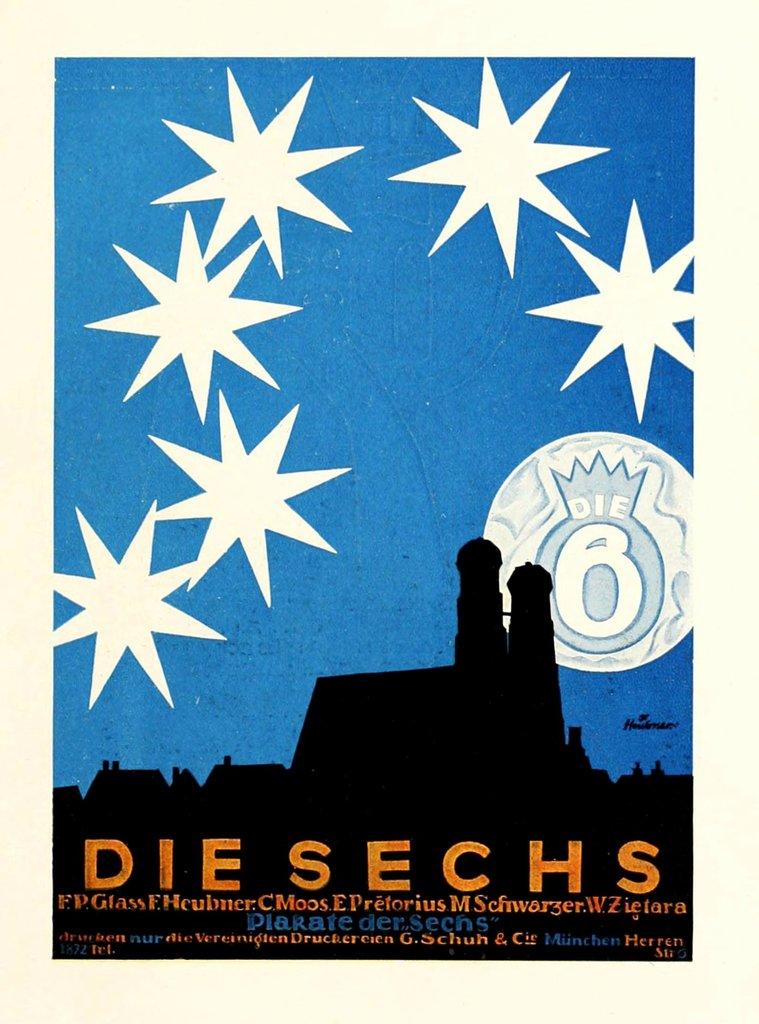What number appears in the background of the artwork?
Ensure brevity in your answer.  6. What are the letters in orange?
Keep it short and to the point. Die sechs. 